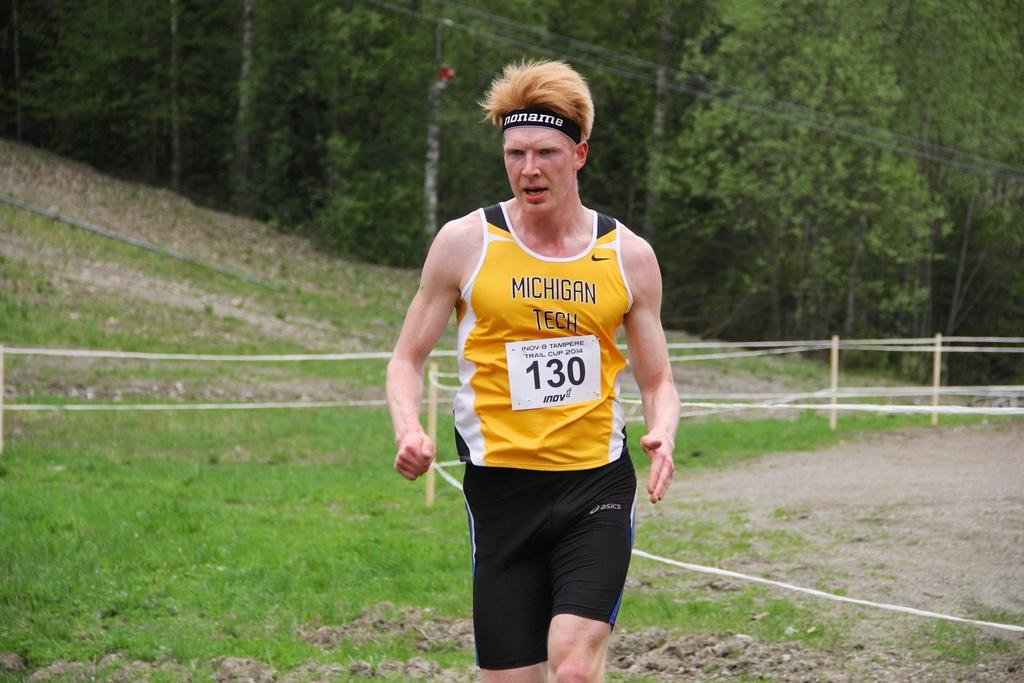<image>
Present a compact description of the photo's key features. a boy who is running with the number 130 on them 